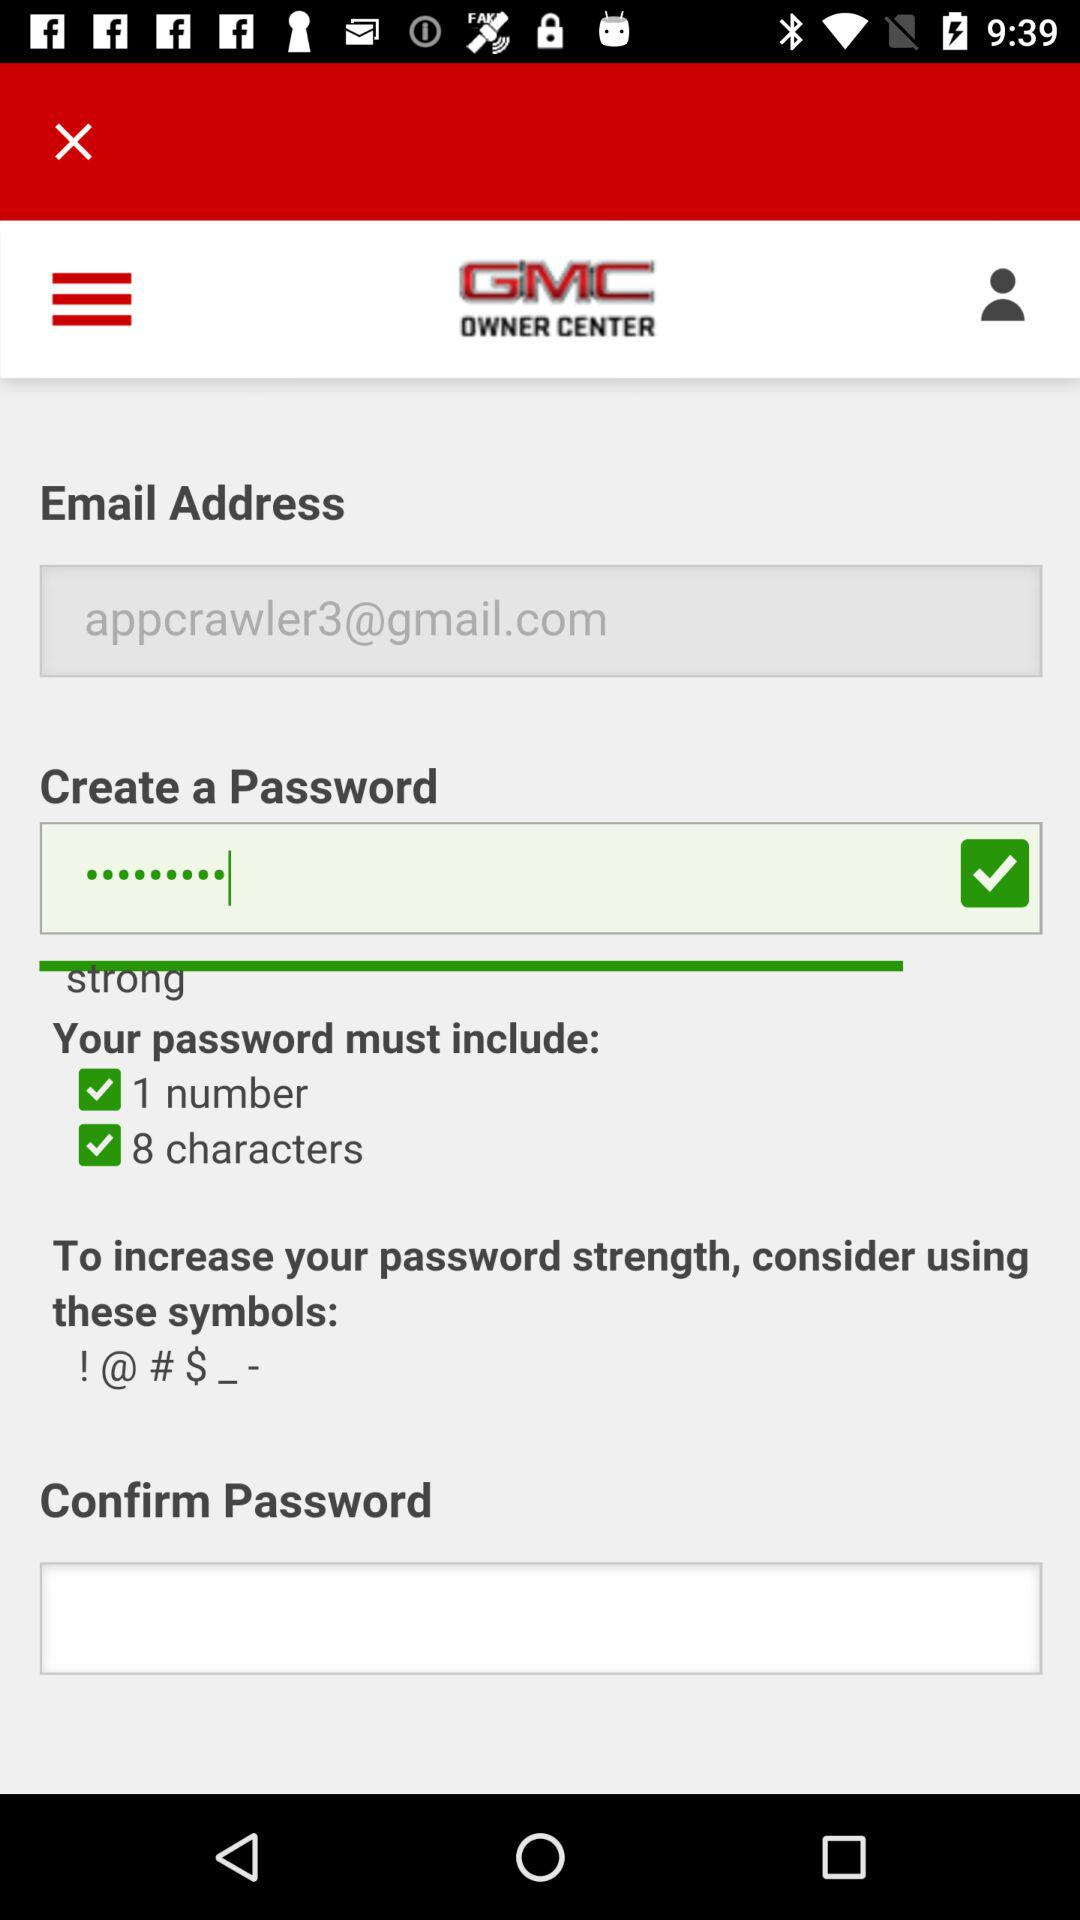Your password should be how many characters? Your password must include 8 characters. 